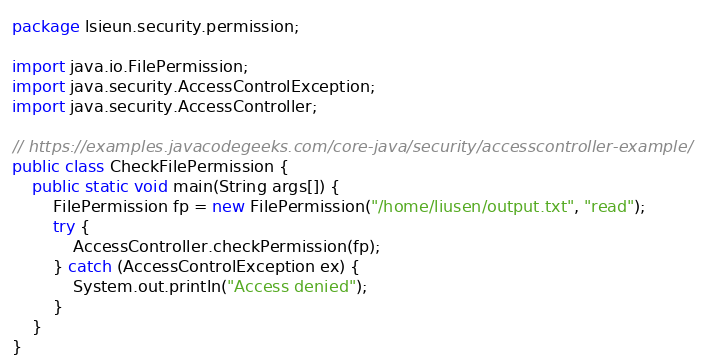Convert code to text. <code><loc_0><loc_0><loc_500><loc_500><_Java_>package lsieun.security.permission;

import java.io.FilePermission;
import java.security.AccessControlException;
import java.security.AccessController;

// https://examples.javacodegeeks.com/core-java/security/accesscontroller-example/
public class CheckFilePermission {
    public static void main(String args[]) {
        FilePermission fp = new FilePermission("/home/liusen/output.txt", "read");
        try {
            AccessController.checkPermission(fp);
        } catch (AccessControlException ex) {
            System.out.println("Access denied");
        }
    }
}
</code> 